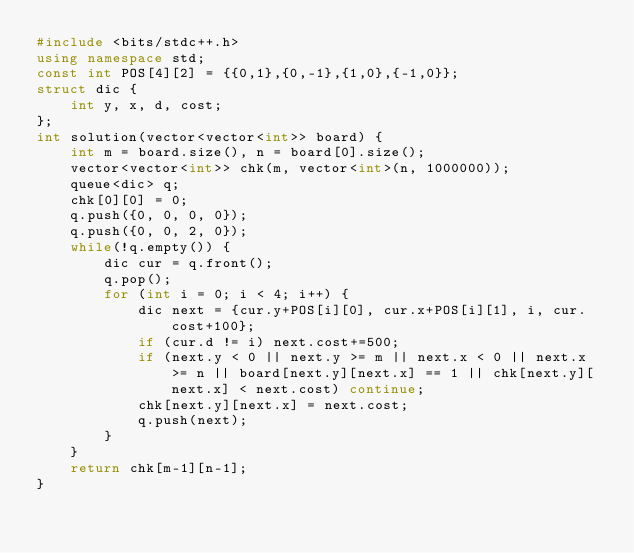<code> <loc_0><loc_0><loc_500><loc_500><_C++_>#include <bits/stdc++.h>
using namespace std;
const int POS[4][2] = {{0,1},{0,-1},{1,0},{-1,0}};
struct dic {
    int y, x, d, cost;
};
int solution(vector<vector<int>> board) {
    int m = board.size(), n = board[0].size();
    vector<vector<int>> chk(m, vector<int>(n, 1000000));
    queue<dic> q;
    chk[0][0] = 0;
    q.push({0, 0, 0, 0});
    q.push({0, 0, 2, 0});
    while(!q.empty()) {
        dic cur = q.front();
        q.pop();
        for (int i = 0; i < 4; i++) {
            dic next = {cur.y+POS[i][0], cur.x+POS[i][1], i, cur.cost+100};
            if (cur.d != i) next.cost+=500;
            if (next.y < 0 || next.y >= m || next.x < 0 || next.x >= n || board[next.y][next.x] == 1 || chk[next.y][next.x] < next.cost) continue;
            chk[next.y][next.x] = next.cost;
            q.push(next);
        }
    }
    return chk[m-1][n-1];
}</code> 